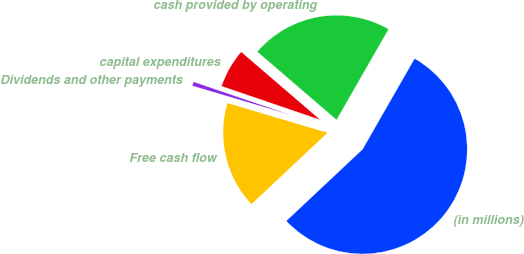Convert chart. <chart><loc_0><loc_0><loc_500><loc_500><pie_chart><fcel>(in millions)<fcel>cash provided by operating<fcel>capital expenditures<fcel>Dividends and other payments<fcel>Free cash flow<nl><fcel>54.71%<fcel>21.99%<fcel>6.06%<fcel>0.65%<fcel>16.59%<nl></chart> 